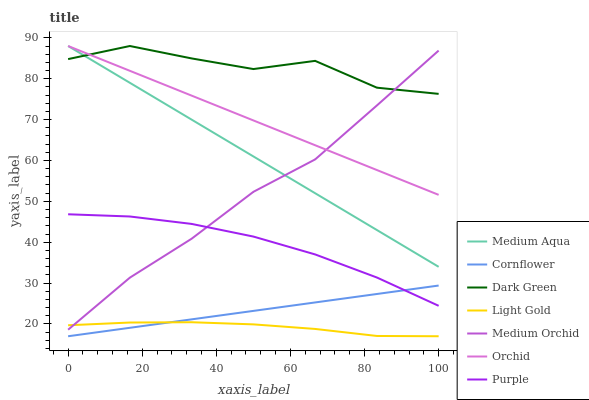Does Light Gold have the minimum area under the curve?
Answer yes or no. Yes. Does Dark Green have the maximum area under the curve?
Answer yes or no. Yes. Does Purple have the minimum area under the curve?
Answer yes or no. No. Does Purple have the maximum area under the curve?
Answer yes or no. No. Is Cornflower the smoothest?
Answer yes or no. Yes. Is Dark Green the roughest?
Answer yes or no. Yes. Is Purple the smoothest?
Answer yes or no. No. Is Purple the roughest?
Answer yes or no. No. Does Cornflower have the lowest value?
Answer yes or no. Yes. Does Purple have the lowest value?
Answer yes or no. No. Does Orchid have the highest value?
Answer yes or no. Yes. Does Purple have the highest value?
Answer yes or no. No. Is Light Gold less than Dark Green?
Answer yes or no. Yes. Is Dark Green greater than Cornflower?
Answer yes or no. Yes. Does Purple intersect Cornflower?
Answer yes or no. Yes. Is Purple less than Cornflower?
Answer yes or no. No. Is Purple greater than Cornflower?
Answer yes or no. No. Does Light Gold intersect Dark Green?
Answer yes or no. No. 